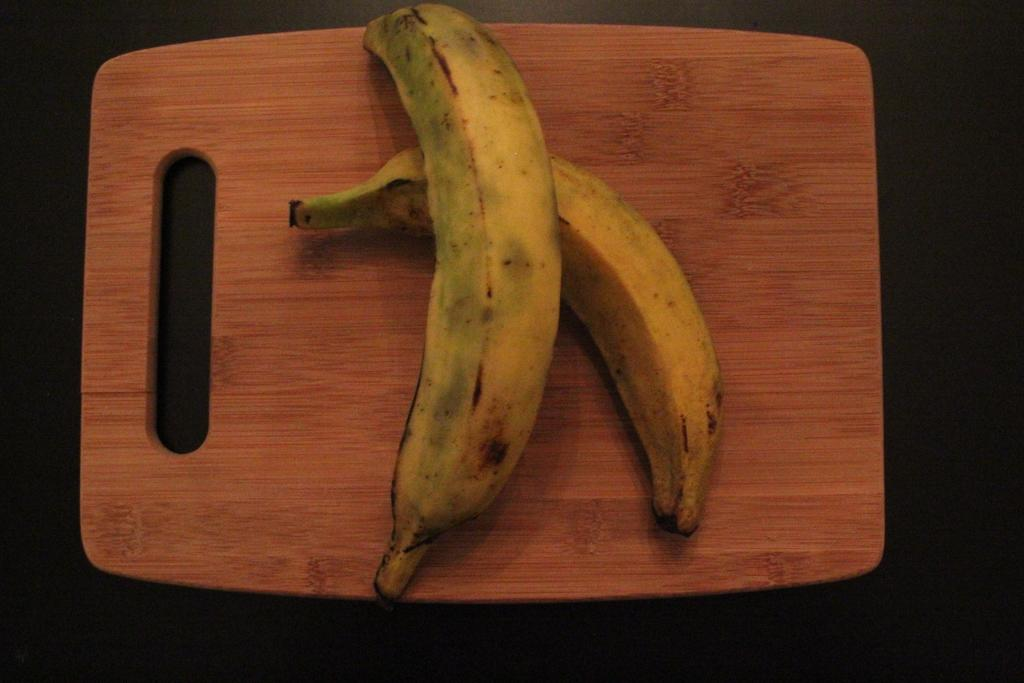What fruit is present in the image? There are two bananas in the image. Where are the bananas placed? The bananas are on a chopping board. What material is the chopping board made of? The chopping board is made of wood. What can be seen below the chopping board in the image? There is a floor visible in the image. What type of tax is being discussed in the image? There is no discussion of tax in the image; it features two bananas on a wooden chopping board with a visible floor. 